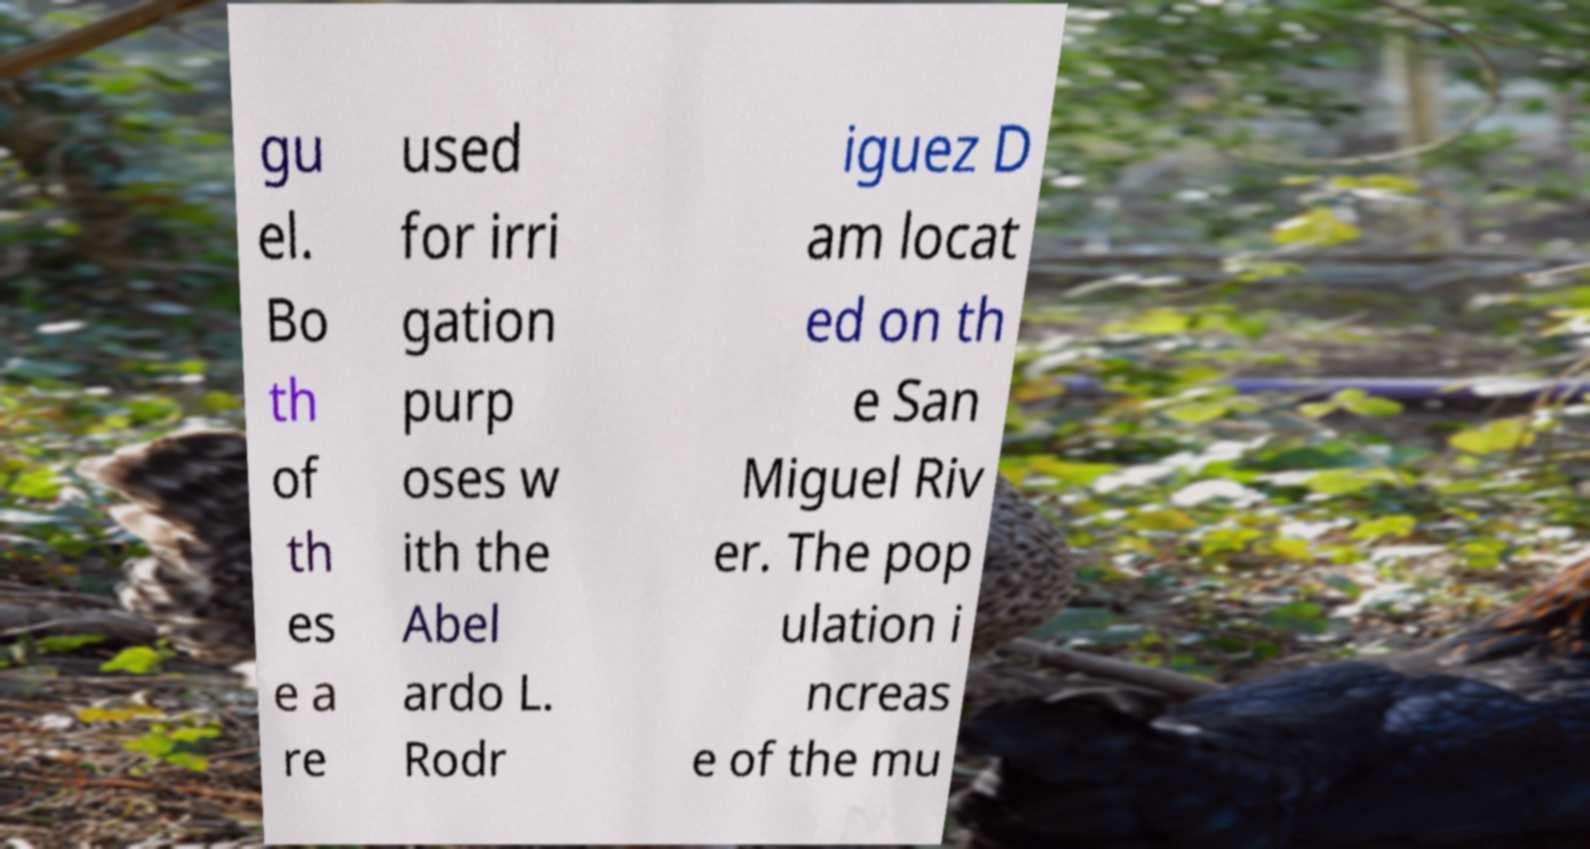Please identify and transcribe the text found in this image. gu el. Bo th of th es e a re used for irri gation purp oses w ith the Abel ardo L. Rodr iguez D am locat ed on th e San Miguel Riv er. The pop ulation i ncreas e of the mu 